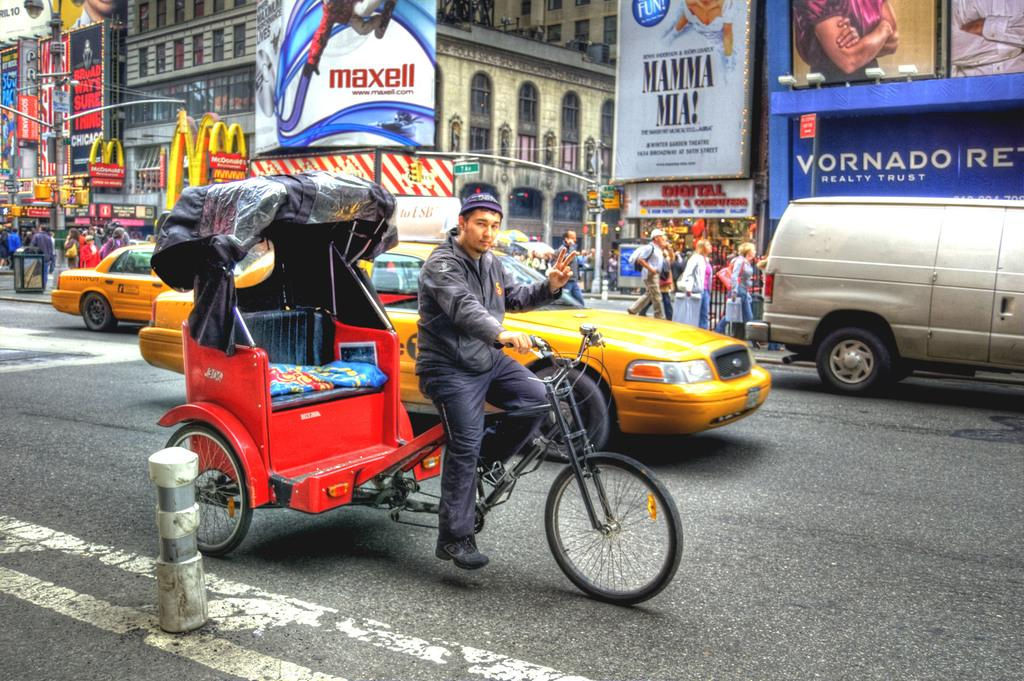<image>
Give a short and clear explanation of the subsequent image. A carriage driver passes a Mamma Mia! banner and a Maxell ad. 